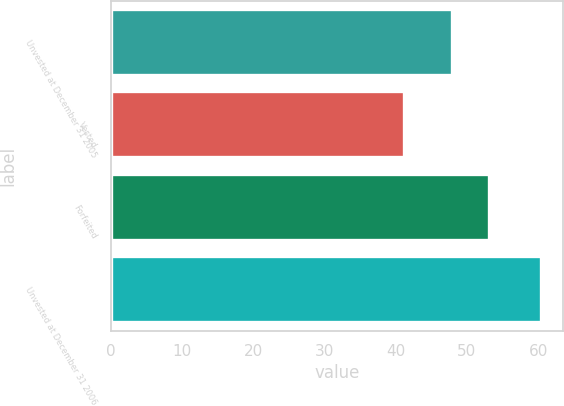<chart> <loc_0><loc_0><loc_500><loc_500><bar_chart><fcel>Unvested at December 31 2005<fcel>Vested<fcel>Forfeited<fcel>Unvested at December 31 2006<nl><fcel>47.94<fcel>41.18<fcel>53.1<fcel>60.42<nl></chart> 